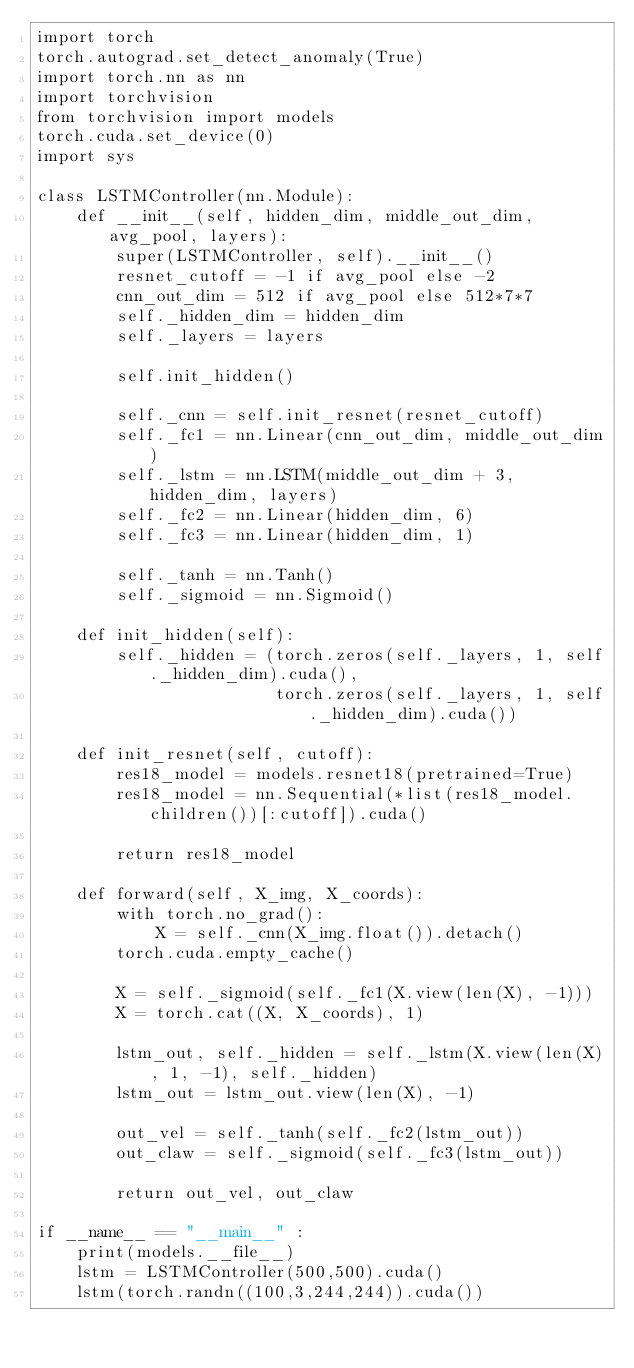Convert code to text. <code><loc_0><loc_0><loc_500><loc_500><_Python_>import torch
torch.autograd.set_detect_anomaly(True)
import torch.nn as nn
import torchvision
from torchvision import models
torch.cuda.set_device(0)
import sys

class LSTMController(nn.Module):
    def __init__(self, hidden_dim, middle_out_dim, avg_pool, layers):
        super(LSTMController, self).__init__()
        resnet_cutoff = -1 if avg_pool else -2
        cnn_out_dim = 512 if avg_pool else 512*7*7
        self._hidden_dim = hidden_dim
        self._layers = layers

        self.init_hidden()

        self._cnn = self.init_resnet(resnet_cutoff)
        self._fc1 = nn.Linear(cnn_out_dim, middle_out_dim)
        self._lstm = nn.LSTM(middle_out_dim + 3, hidden_dim, layers)
        self._fc2 = nn.Linear(hidden_dim, 6)
        self._fc3 = nn.Linear(hidden_dim, 1)

        self._tanh = nn.Tanh()
        self._sigmoid = nn.Sigmoid()

    def init_hidden(self):
        self._hidden = (torch.zeros(self._layers, 1, self._hidden_dim).cuda(),
                        torch.zeros(self._layers, 1, self._hidden_dim).cuda())

    def init_resnet(self, cutoff):
        res18_model = models.resnet18(pretrained=True)
        res18_model = nn.Sequential(*list(res18_model.children())[:cutoff]).cuda()

        return res18_model

    def forward(self, X_img, X_coords):
        with torch.no_grad():
            X = self._cnn(X_img.float()).detach()
        torch.cuda.empty_cache()

        X = self._sigmoid(self._fc1(X.view(len(X), -1)))
        X = torch.cat((X, X_coords), 1)

        lstm_out, self._hidden = self._lstm(X.view(len(X), 1, -1), self._hidden)
        lstm_out = lstm_out.view(len(X), -1)

        out_vel = self._tanh(self._fc2(lstm_out))
        out_claw = self._sigmoid(self._fc3(lstm_out))
        
        return out_vel, out_claw

if __name__ == "__main__" :
    print(models.__file__)
    lstm = LSTMController(500,500).cuda()
    lstm(torch.randn((100,3,244,244)).cuda())

</code> 